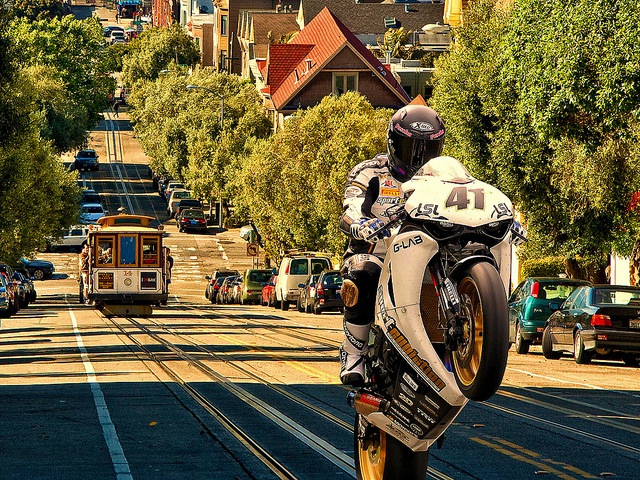Describe the objects in this image and their specific colors. I can see motorcycle in darkgreen, black, lightyellow, and tan tones, people in darkgreen, black, beige, gray, and tan tones, car in darkgreen, black, tan, olive, and khaki tones, train in darkgreen, black, maroon, brown, and khaki tones, and car in darkgreen, black, olive, maroon, and khaki tones in this image. 